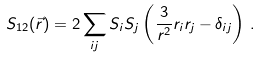<formula> <loc_0><loc_0><loc_500><loc_500>S _ { 1 2 } ( \vec { r } ) = 2 \sum _ { i j } S _ { i } S _ { j } \left ( \frac { 3 } { r ^ { 2 } } r _ { i } r _ { j } - \delta _ { i j } \right ) \, .</formula> 